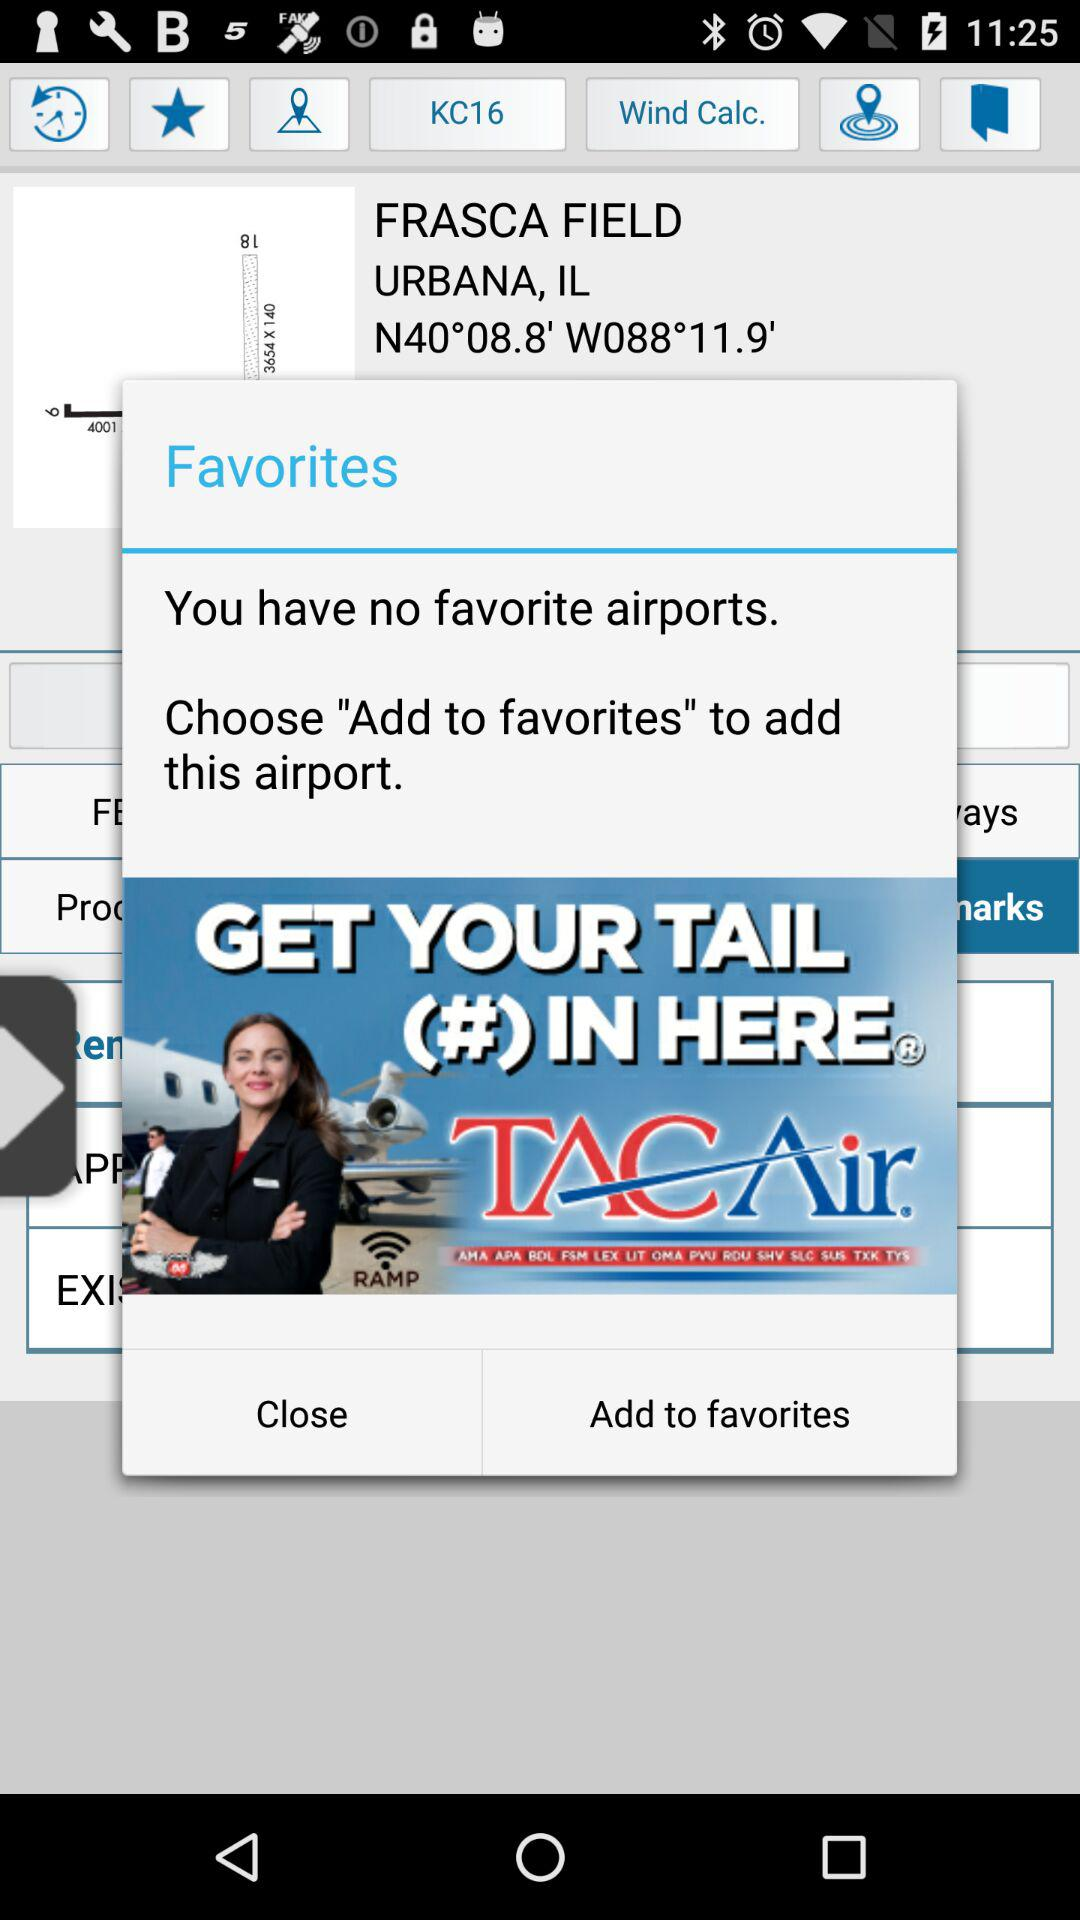What is the street address of the airport?
When the provided information is insufficient, respond with <no answer>. <no answer> 